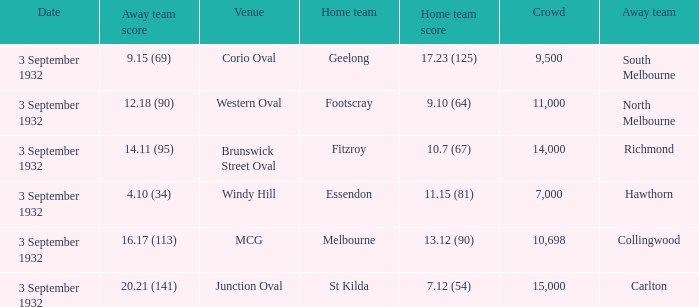What is the total Crowd number for the team that has an Away team score of 12.18 (90)? 11000.0. 